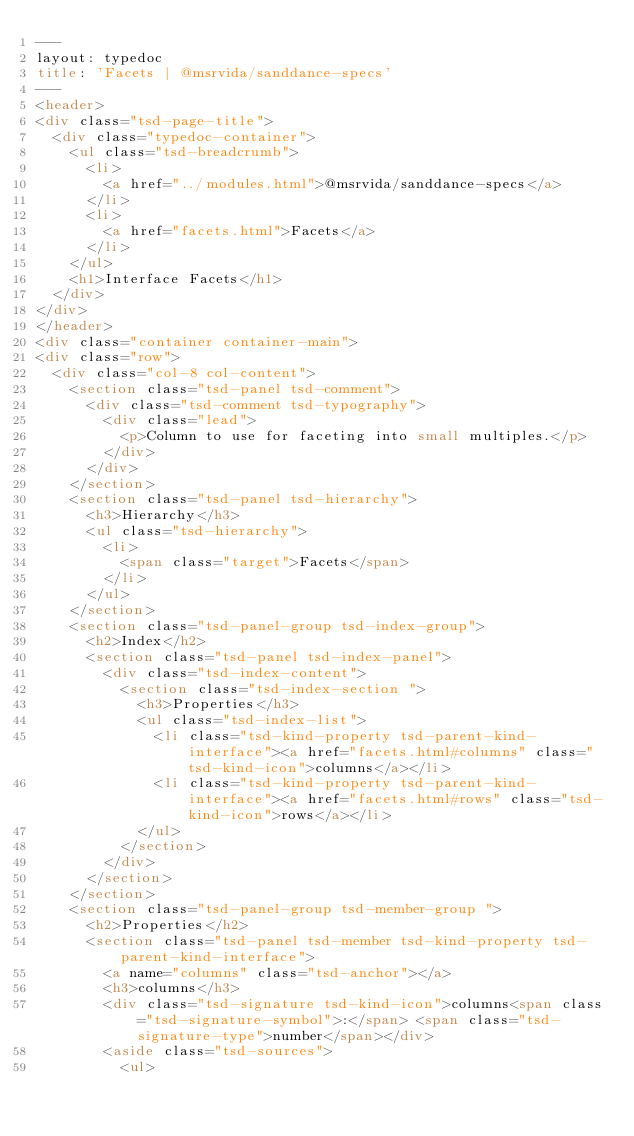Convert code to text. <code><loc_0><loc_0><loc_500><loc_500><_HTML_>---
layout: typedoc
title: 'Facets | @msrvida/sanddance-specs'
---
<header>
<div class="tsd-page-title">
	<div class="typedoc-container">
		<ul class="tsd-breadcrumb">
			<li>
				<a href="../modules.html">@msrvida/sanddance-specs</a>
			</li>
			<li>
				<a href="facets.html">Facets</a>
			</li>
		</ul>
		<h1>Interface Facets</h1>
	</div>
</div>
</header>
<div class="container container-main">
<div class="row">
	<div class="col-8 col-content">
		<section class="tsd-panel tsd-comment">
			<div class="tsd-comment tsd-typography">
				<div class="lead">
					<p>Column to use for faceting into small multiples.</p>
				</div>
			</div>
		</section>
		<section class="tsd-panel tsd-hierarchy">
			<h3>Hierarchy</h3>
			<ul class="tsd-hierarchy">
				<li>
					<span class="target">Facets</span>
				</li>
			</ul>
		</section>
		<section class="tsd-panel-group tsd-index-group">
			<h2>Index</h2>
			<section class="tsd-panel tsd-index-panel">
				<div class="tsd-index-content">
					<section class="tsd-index-section ">
						<h3>Properties</h3>
						<ul class="tsd-index-list">
							<li class="tsd-kind-property tsd-parent-kind-interface"><a href="facets.html#columns" class="tsd-kind-icon">columns</a></li>
							<li class="tsd-kind-property tsd-parent-kind-interface"><a href="facets.html#rows" class="tsd-kind-icon">rows</a></li>
						</ul>
					</section>
				</div>
			</section>
		</section>
		<section class="tsd-panel-group tsd-member-group ">
			<h2>Properties</h2>
			<section class="tsd-panel tsd-member tsd-kind-property tsd-parent-kind-interface">
				<a name="columns" class="tsd-anchor"></a>
				<h3>columns</h3>
				<div class="tsd-signature tsd-kind-icon">columns<span class="tsd-signature-symbol">:</span> <span class="tsd-signature-type">number</span></div>
				<aside class="tsd-sources">
					<ul></code> 